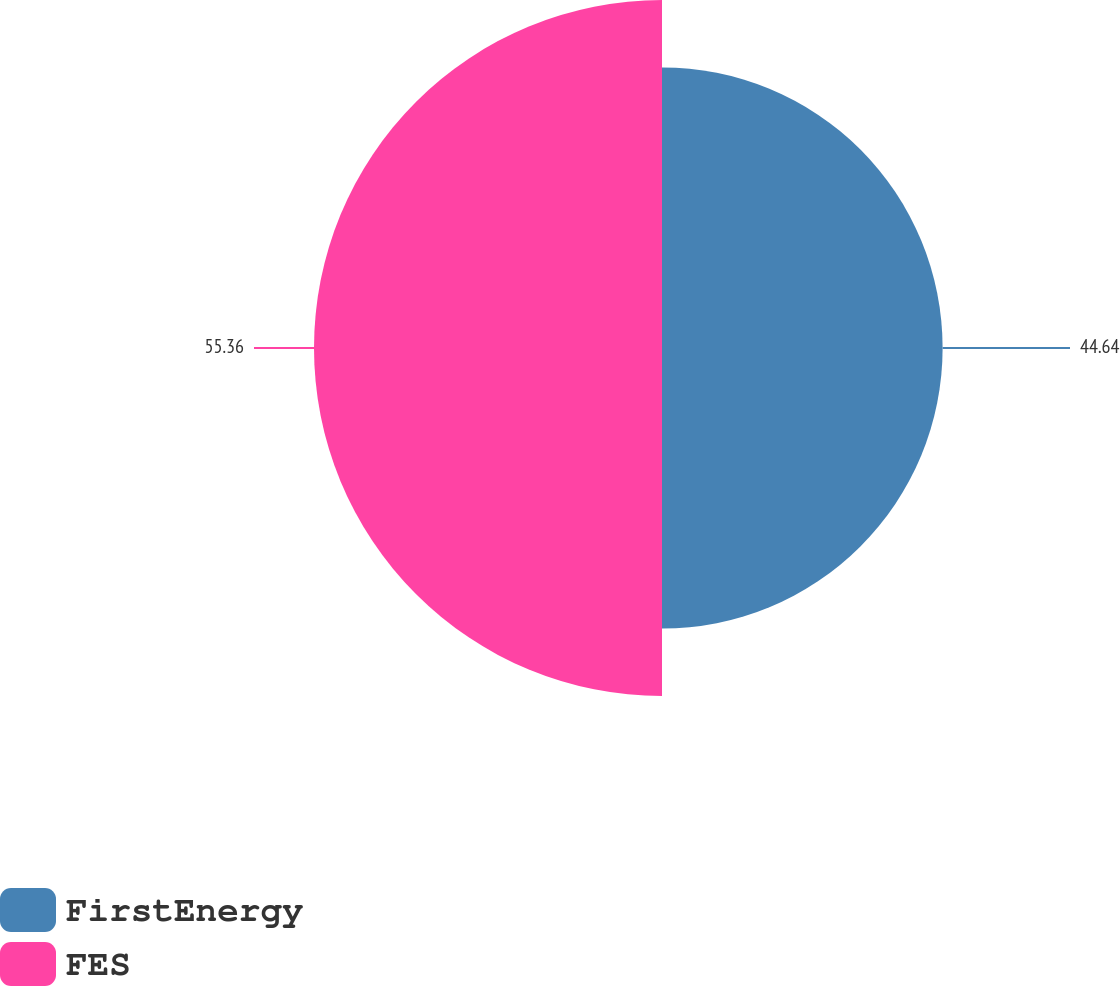<chart> <loc_0><loc_0><loc_500><loc_500><pie_chart><fcel>FirstEnergy<fcel>FES<nl><fcel>44.64%<fcel>55.36%<nl></chart> 